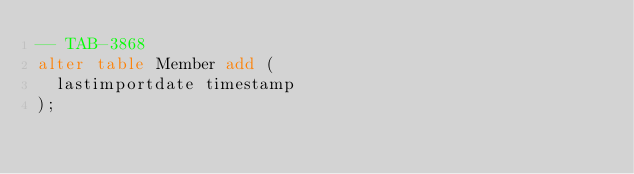Convert code to text. <code><loc_0><loc_0><loc_500><loc_500><_SQL_>-- TAB-3868
alter table Member add (
  lastimportdate timestamp
);
</code> 